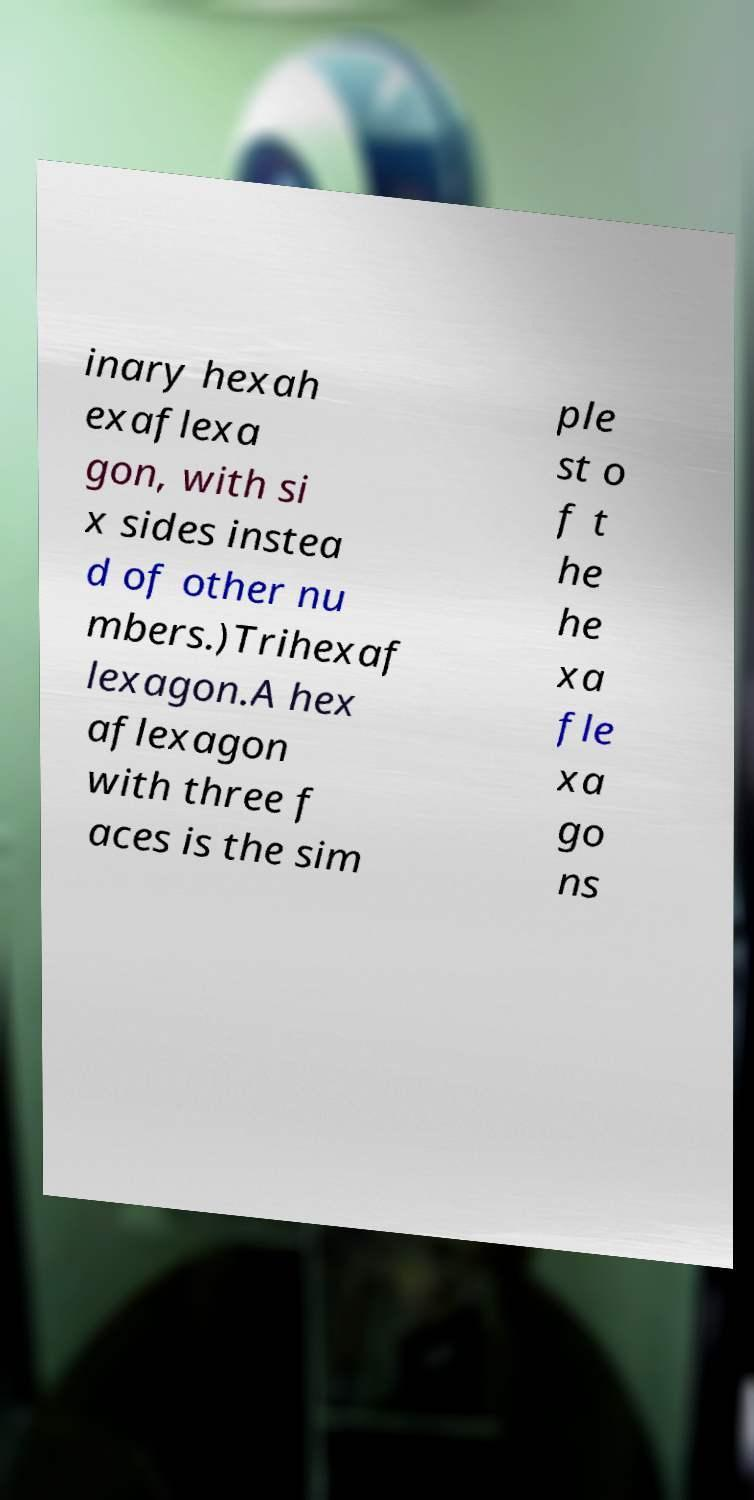I need the written content from this picture converted into text. Can you do that? inary hexah exaflexa gon, with si x sides instea d of other nu mbers.)Trihexaf lexagon.A hex aflexagon with three f aces is the sim ple st o f t he he xa fle xa go ns 